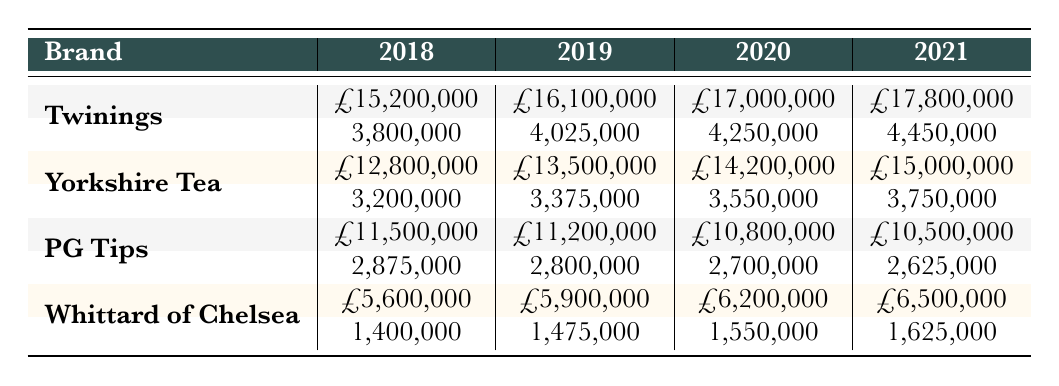What were the sales figures for Twinings in 2020? Referring to the row for Twinings under the year 2020 in the table, the sales figure is £17,000,000.
Answer: £17,000,000 Which brand had the highest sales in 2021? Looking at the sales figures for each brand in 2021, Twinings had the highest sales at £17,800,000, compared to the other brands.
Answer: Twinings What is the total sales amount for Yorkshire Tea from 2018 to 2021? The sales figures for Yorkshire Tea are £12,800,000 (2018) + £13,500,000 (2019) + £14,200,000 (2020) + £15,000,000 (2021) = £55,500,000.
Answer: £55,500,000 Did PG Tips experience an increase in sales from 2018 to 2021? Comparing the sales figures: £11,500,000 (2018) > £11,200,000 (2019) > £10,800,000 (2020) > £10,500,000 (2021) shows a continuous decrease in sales. Therefore, PG Tips did not experience an increase.
Answer: No What was the average sales figure for Whittard of Chelsea over the years? The sales figures for Whittard of Chelsea are £5,600,000 (2018), £5,900,000 (2019), £6,200,000 (2020), and £6,500,000 (2021). The total is £5,600,000 + £5,900,000 + £6,200,000 + £6,500,000 = £24,200,000, and since there are 4 years, the average is £24,200,000 / 4 = £6,050,000.
Answer: £6,050,000 Which year saw the lowest sales for PG Tips? Checking the sales figures for PG Tips, we find £11,500,000 (2018), £11,200,000 (2019), £10,800,000 (2020), and £10,500,000 (2021). The lowest is £10,500,000 in 2021.
Answer: 2021 